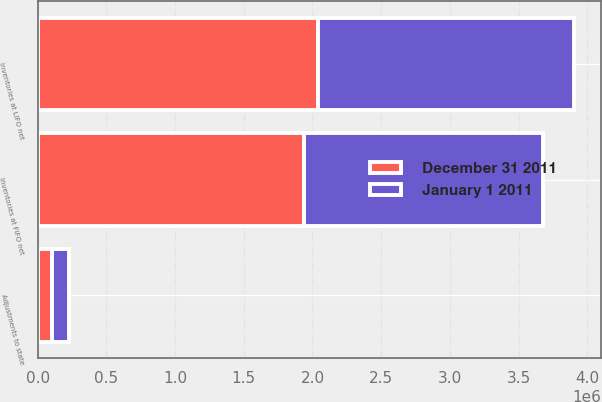<chart> <loc_0><loc_0><loc_500><loc_500><stacked_bar_chart><ecel><fcel>Inventories at FIFO net<fcel>Adjustments to state<fcel>Inventories at LIFO net<nl><fcel>December 31 2011<fcel>1.94106e+06<fcel>102103<fcel>2.04316e+06<nl><fcel>January 1 2011<fcel>1.73706e+06<fcel>126811<fcel>1.86387e+06<nl></chart> 